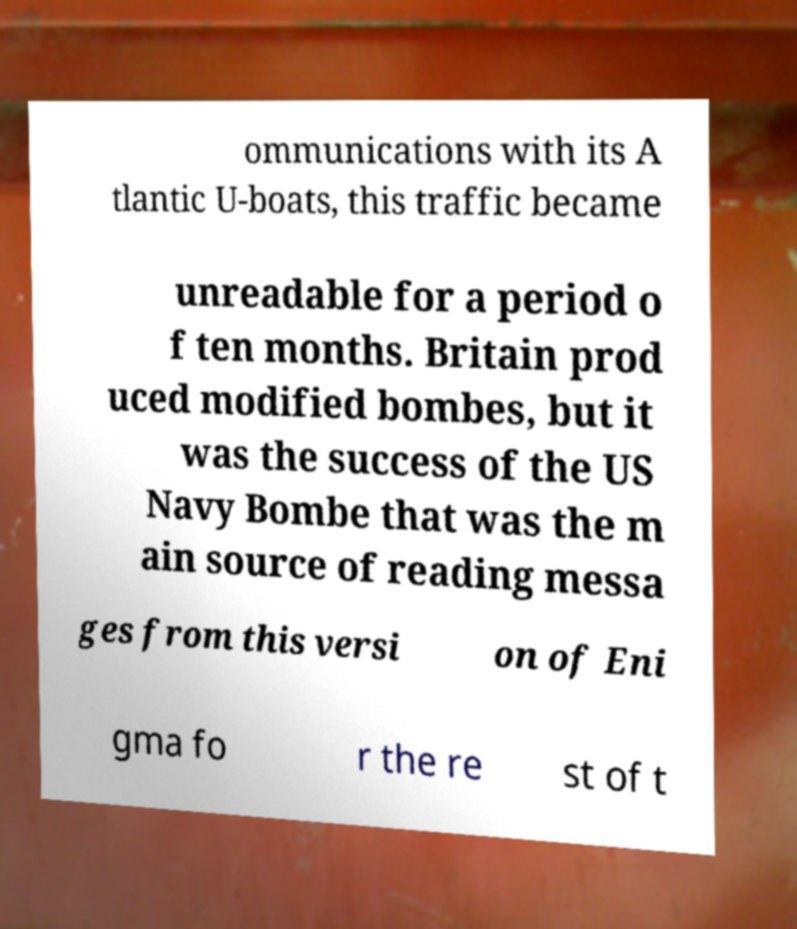Can you accurately transcribe the text from the provided image for me? ommunications with its A tlantic U-boats, this traffic became unreadable for a period o f ten months. Britain prod uced modified bombes, but it was the success of the US Navy Bombe that was the m ain source of reading messa ges from this versi on of Eni gma fo r the re st of t 